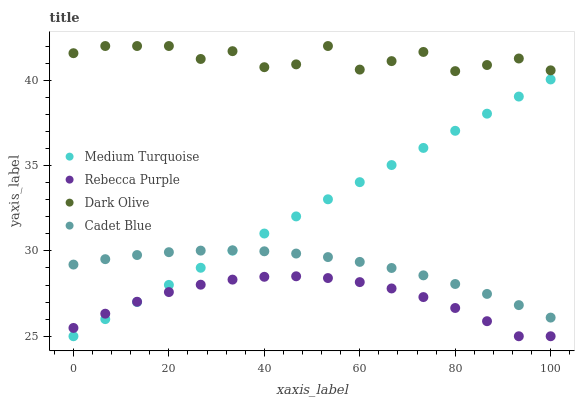Does Rebecca Purple have the minimum area under the curve?
Answer yes or no. Yes. Does Dark Olive have the maximum area under the curve?
Answer yes or no. Yes. Does Dark Olive have the minimum area under the curve?
Answer yes or no. No. Does Rebecca Purple have the maximum area under the curve?
Answer yes or no. No. Is Medium Turquoise the smoothest?
Answer yes or no. Yes. Is Dark Olive the roughest?
Answer yes or no. Yes. Is Rebecca Purple the smoothest?
Answer yes or no. No. Is Rebecca Purple the roughest?
Answer yes or no. No. Does Rebecca Purple have the lowest value?
Answer yes or no. Yes. Does Dark Olive have the lowest value?
Answer yes or no. No. Does Dark Olive have the highest value?
Answer yes or no. Yes. Does Rebecca Purple have the highest value?
Answer yes or no. No. Is Rebecca Purple less than Cadet Blue?
Answer yes or no. Yes. Is Dark Olive greater than Medium Turquoise?
Answer yes or no. Yes. Does Medium Turquoise intersect Rebecca Purple?
Answer yes or no. Yes. Is Medium Turquoise less than Rebecca Purple?
Answer yes or no. No. Is Medium Turquoise greater than Rebecca Purple?
Answer yes or no. No. Does Rebecca Purple intersect Cadet Blue?
Answer yes or no. No. 